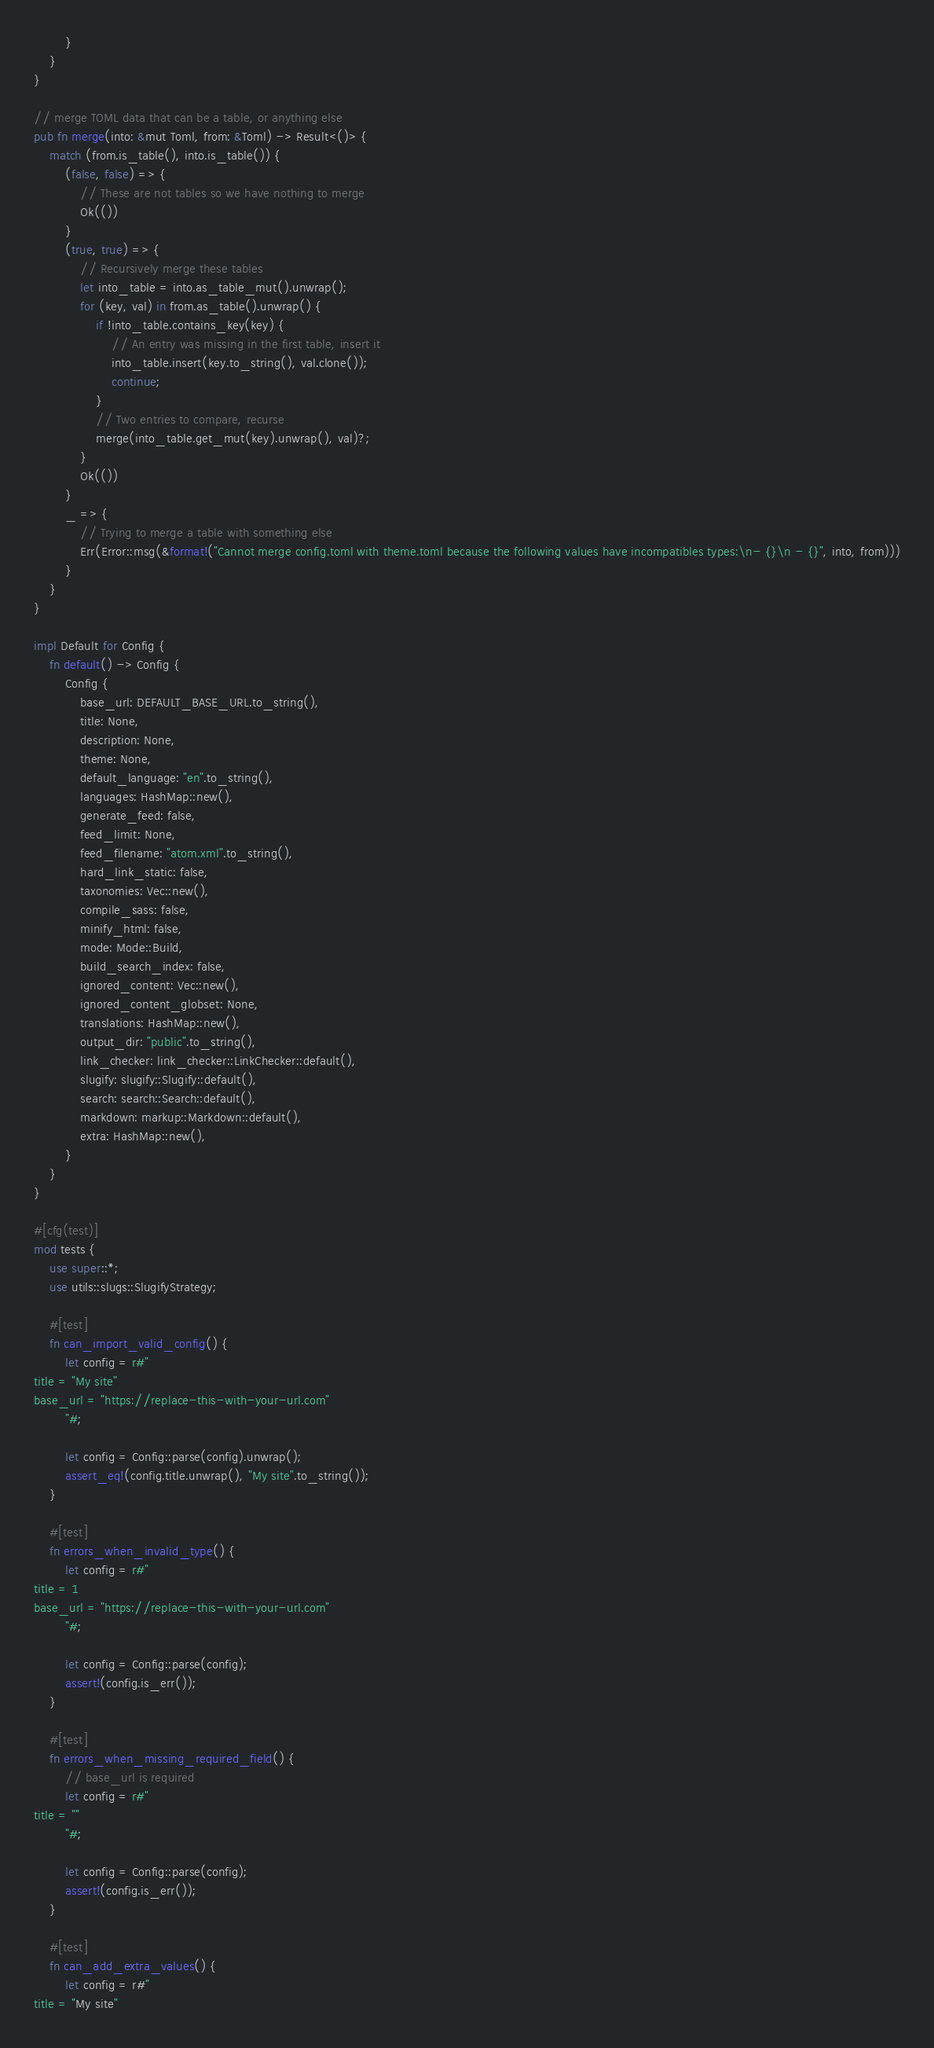<code> <loc_0><loc_0><loc_500><loc_500><_Rust_>        }
    }
}

// merge TOML data that can be a table, or anything else
pub fn merge(into: &mut Toml, from: &Toml) -> Result<()> {
    match (from.is_table(), into.is_table()) {
        (false, false) => {
            // These are not tables so we have nothing to merge
            Ok(())
        }
        (true, true) => {
            // Recursively merge these tables
            let into_table = into.as_table_mut().unwrap();
            for (key, val) in from.as_table().unwrap() {
                if !into_table.contains_key(key) {
                    // An entry was missing in the first table, insert it
                    into_table.insert(key.to_string(), val.clone());
                    continue;
                }
                // Two entries to compare, recurse
                merge(into_table.get_mut(key).unwrap(), val)?;
            }
            Ok(())
        }
        _ => {
            // Trying to merge a table with something else
            Err(Error::msg(&format!("Cannot merge config.toml with theme.toml because the following values have incompatibles types:\n- {}\n - {}", into, from)))
        }
    }
}

impl Default for Config {
    fn default() -> Config {
        Config {
            base_url: DEFAULT_BASE_URL.to_string(),
            title: None,
            description: None,
            theme: None,
            default_language: "en".to_string(),
            languages: HashMap::new(),
            generate_feed: false,
            feed_limit: None,
            feed_filename: "atom.xml".to_string(),
            hard_link_static: false,
            taxonomies: Vec::new(),
            compile_sass: false,
            minify_html: false,
            mode: Mode::Build,
            build_search_index: false,
            ignored_content: Vec::new(),
            ignored_content_globset: None,
            translations: HashMap::new(),
            output_dir: "public".to_string(),
            link_checker: link_checker::LinkChecker::default(),
            slugify: slugify::Slugify::default(),
            search: search::Search::default(),
            markdown: markup::Markdown::default(),
            extra: HashMap::new(),
        }
    }
}

#[cfg(test)]
mod tests {
    use super::*;
    use utils::slugs::SlugifyStrategy;

    #[test]
    fn can_import_valid_config() {
        let config = r#"
title = "My site"
base_url = "https://replace-this-with-your-url.com"
        "#;

        let config = Config::parse(config).unwrap();
        assert_eq!(config.title.unwrap(), "My site".to_string());
    }

    #[test]
    fn errors_when_invalid_type() {
        let config = r#"
title = 1
base_url = "https://replace-this-with-your-url.com"
        "#;

        let config = Config::parse(config);
        assert!(config.is_err());
    }

    #[test]
    fn errors_when_missing_required_field() {
        // base_url is required
        let config = r#"
title = ""
        "#;

        let config = Config::parse(config);
        assert!(config.is_err());
    }

    #[test]
    fn can_add_extra_values() {
        let config = r#"
title = "My site"</code> 